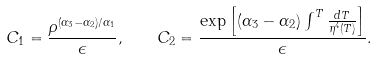Convert formula to latex. <formula><loc_0><loc_0><loc_500><loc_500>C _ { 1 } = \frac { \rho ^ { ( \alpha _ { 3 } - \alpha _ { 2 } ) / \alpha _ { 1 } } } { \epsilon } , \quad C _ { 2 } = \frac { \exp \left [ ( \alpha _ { 3 } - \alpha _ { 2 } ) \int ^ { T } \frac { d T } { \eta ^ { 4 } ( T ) } \right ] } { \epsilon } .</formula> 